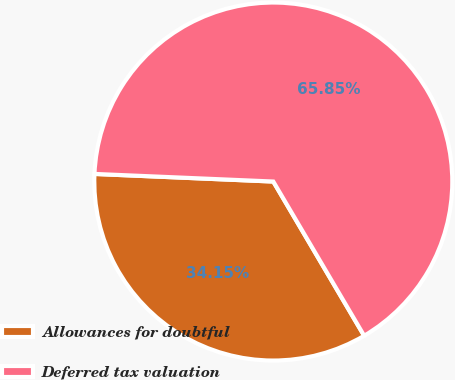Convert chart to OTSL. <chart><loc_0><loc_0><loc_500><loc_500><pie_chart><fcel>Allowances for doubtful<fcel>Deferred tax valuation<nl><fcel>34.15%<fcel>65.85%<nl></chart> 